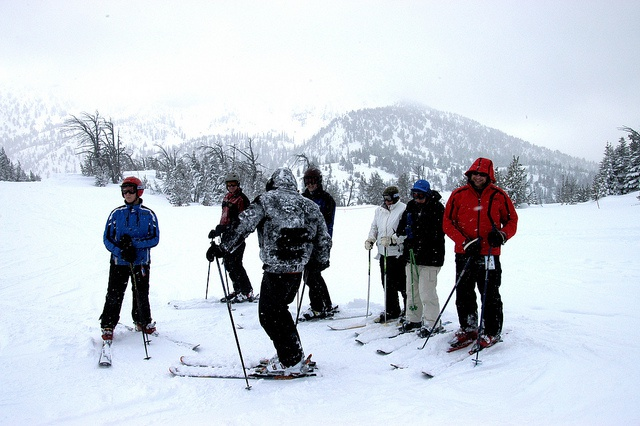Describe the objects in this image and their specific colors. I can see people in lavender, black, gray, and darkgray tones, people in lavender, black, maroon, and gray tones, people in lavender, black, navy, white, and gray tones, people in lavender, black, gray, and navy tones, and people in lavender, black, darkgray, lightgray, and gray tones in this image. 